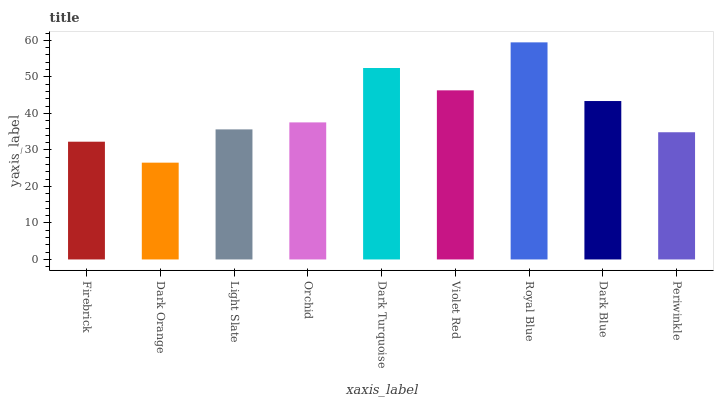Is Dark Orange the minimum?
Answer yes or no. Yes. Is Royal Blue the maximum?
Answer yes or no. Yes. Is Light Slate the minimum?
Answer yes or no. No. Is Light Slate the maximum?
Answer yes or no. No. Is Light Slate greater than Dark Orange?
Answer yes or no. Yes. Is Dark Orange less than Light Slate?
Answer yes or no. Yes. Is Dark Orange greater than Light Slate?
Answer yes or no. No. Is Light Slate less than Dark Orange?
Answer yes or no. No. Is Orchid the high median?
Answer yes or no. Yes. Is Orchid the low median?
Answer yes or no. Yes. Is Dark Turquoise the high median?
Answer yes or no. No. Is Dark Orange the low median?
Answer yes or no. No. 